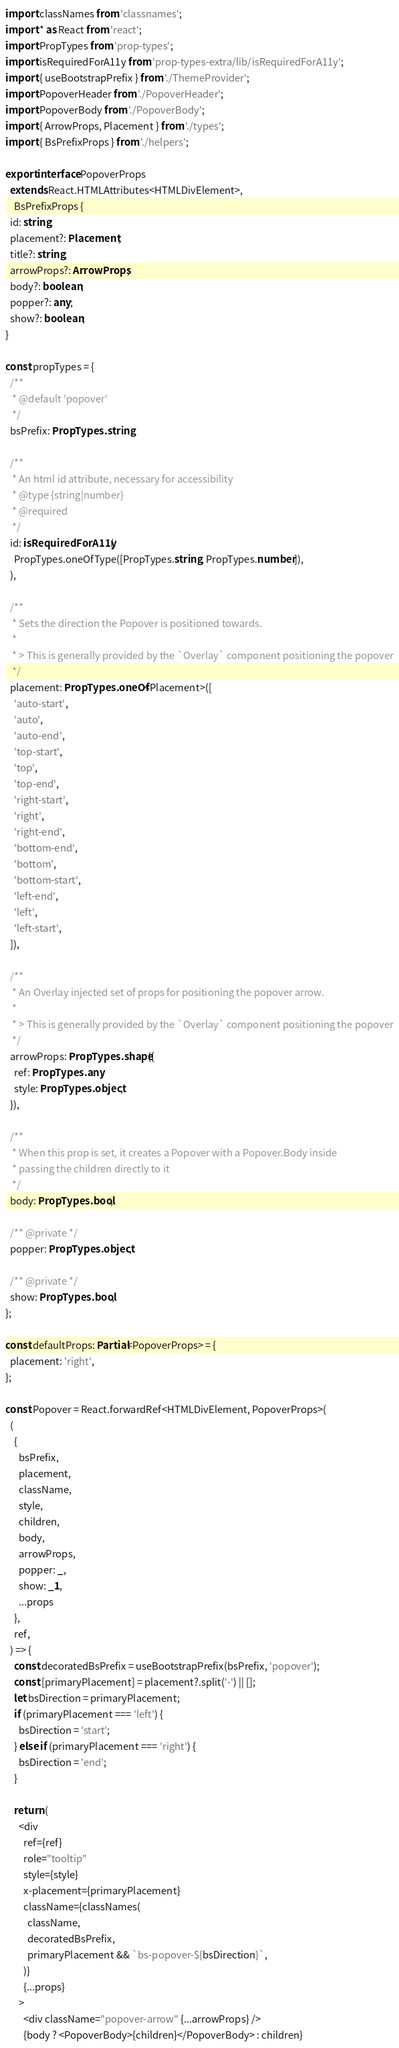<code> <loc_0><loc_0><loc_500><loc_500><_TypeScript_>import classNames from 'classnames';
import * as React from 'react';
import PropTypes from 'prop-types';
import isRequiredForA11y from 'prop-types-extra/lib/isRequiredForA11y';
import { useBootstrapPrefix } from './ThemeProvider';
import PopoverHeader from './PopoverHeader';
import PopoverBody from './PopoverBody';
import { ArrowProps, Placement } from './types';
import { BsPrefixProps } from './helpers';

export interface PopoverProps
  extends React.HTMLAttributes<HTMLDivElement>,
    BsPrefixProps {
  id: string;
  placement?: Placement;
  title?: string;
  arrowProps?: ArrowProps;
  body?: boolean;
  popper?: any;
  show?: boolean;
}

const propTypes = {
  /**
   * @default 'popover'
   */
  bsPrefix: PropTypes.string,

  /**
   * An html id attribute, necessary for accessibility
   * @type {string|number}
   * @required
   */
  id: isRequiredForA11y(
    PropTypes.oneOfType([PropTypes.string, PropTypes.number]),
  ),

  /**
   * Sets the direction the Popover is positioned towards.
   *
   * > This is generally provided by the `Overlay` component positioning the popover
   */
  placement: PropTypes.oneOf<Placement>([
    'auto-start',
    'auto',
    'auto-end',
    'top-start',
    'top',
    'top-end',
    'right-start',
    'right',
    'right-end',
    'bottom-end',
    'bottom',
    'bottom-start',
    'left-end',
    'left',
    'left-start',
  ]),

  /**
   * An Overlay injected set of props for positioning the popover arrow.
   *
   * > This is generally provided by the `Overlay` component positioning the popover
   */
  arrowProps: PropTypes.shape({
    ref: PropTypes.any,
    style: PropTypes.object,
  }),

  /**
   * When this prop is set, it creates a Popover with a Popover.Body inside
   * passing the children directly to it
   */
  body: PropTypes.bool,

  /** @private */
  popper: PropTypes.object,

  /** @private */
  show: PropTypes.bool,
};

const defaultProps: Partial<PopoverProps> = {
  placement: 'right',
};

const Popover = React.forwardRef<HTMLDivElement, PopoverProps>(
  (
    {
      bsPrefix,
      placement,
      className,
      style,
      children,
      body,
      arrowProps,
      popper: _,
      show: _1,
      ...props
    },
    ref,
  ) => {
    const decoratedBsPrefix = useBootstrapPrefix(bsPrefix, 'popover');
    const [primaryPlacement] = placement?.split('-') || [];
    let bsDirection = primaryPlacement;
    if (primaryPlacement === 'left') {
      bsDirection = 'start';
    } else if (primaryPlacement === 'right') {
      bsDirection = 'end';
    }

    return (
      <div
        ref={ref}
        role="tooltip"
        style={style}
        x-placement={primaryPlacement}
        className={classNames(
          className,
          decoratedBsPrefix,
          primaryPlacement && `bs-popover-${bsDirection}`,
        )}
        {...props}
      >
        <div className="popover-arrow" {...arrowProps} />
        {body ? <PopoverBody>{children}</PopoverBody> : children}</code> 